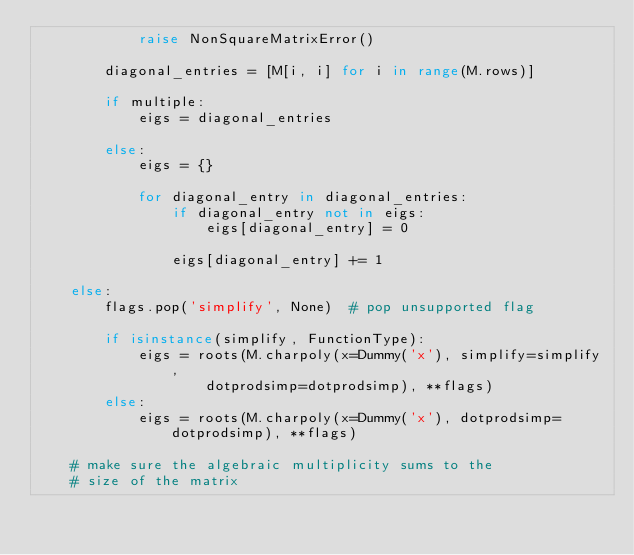<code> <loc_0><loc_0><loc_500><loc_500><_Python_>            raise NonSquareMatrixError()

        diagonal_entries = [M[i, i] for i in range(M.rows)]

        if multiple:
            eigs = diagonal_entries

        else:
            eigs = {}

            for diagonal_entry in diagonal_entries:
                if diagonal_entry not in eigs:
                    eigs[diagonal_entry] = 0

                eigs[diagonal_entry] += 1

    else:
        flags.pop('simplify', None)  # pop unsupported flag

        if isinstance(simplify, FunctionType):
            eigs = roots(M.charpoly(x=Dummy('x'), simplify=simplify,
                    dotprodsimp=dotprodsimp), **flags)
        else:
            eigs = roots(M.charpoly(x=Dummy('x'), dotprodsimp=dotprodsimp), **flags)

    # make sure the algebraic multiplicity sums to the
    # size of the matrix</code> 